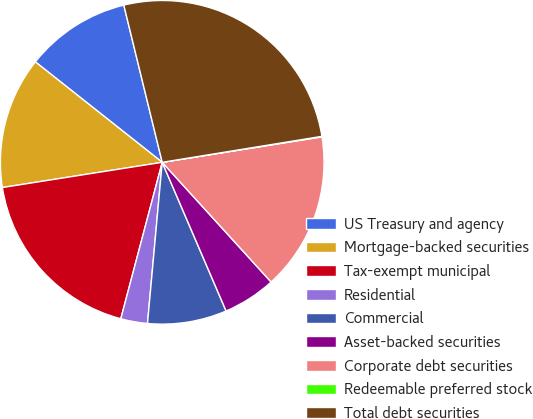<chart> <loc_0><loc_0><loc_500><loc_500><pie_chart><fcel>US Treasury and agency<fcel>Mortgage-backed securities<fcel>Tax-exempt municipal<fcel>Residential<fcel>Commercial<fcel>Asset-backed securities<fcel>Corporate debt securities<fcel>Redeemable preferred stock<fcel>Total debt securities<nl><fcel>10.53%<fcel>13.15%<fcel>18.39%<fcel>2.67%<fcel>7.91%<fcel>5.29%<fcel>15.77%<fcel>0.05%<fcel>26.25%<nl></chart> 